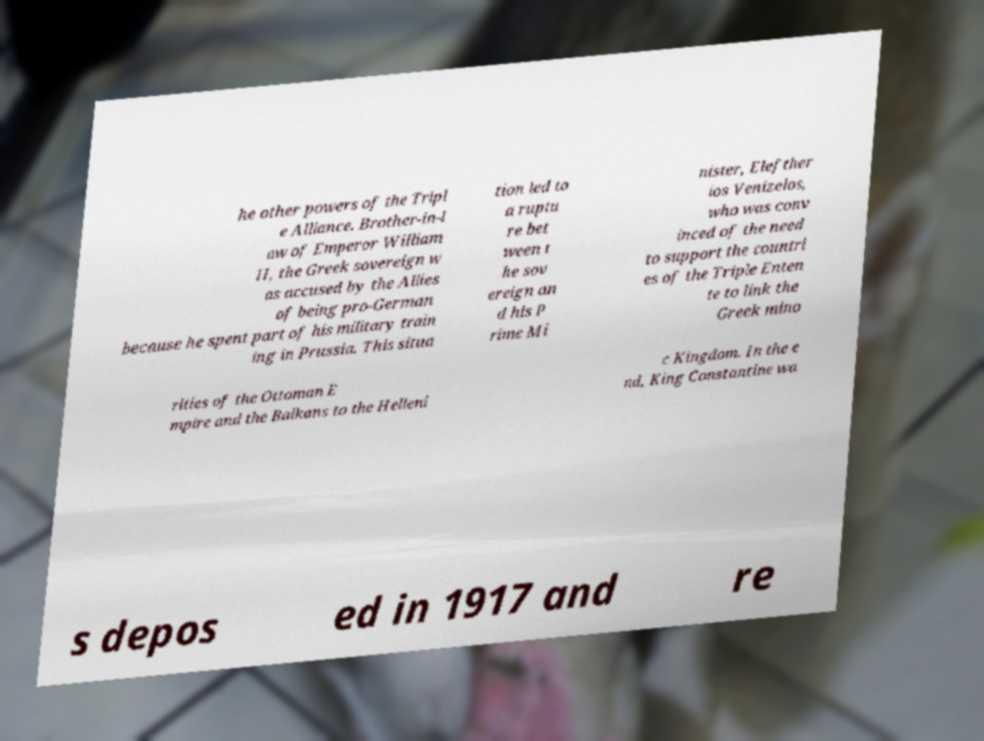What messages or text are displayed in this image? I need them in a readable, typed format. he other powers of the Tripl e Alliance. Brother-in-l aw of Emperor William II, the Greek sovereign w as accused by the Allies of being pro-German because he spent part of his military train ing in Prussia. This situa tion led to a ruptu re bet ween t he sov ereign an d his P rime Mi nister, Elefther ios Venizelos, who was conv inced of the need to support the countri es of the Triple Enten te to link the Greek mino rities of the Ottoman E mpire and the Balkans to the Helleni c Kingdom. In the e nd, King Constantine wa s depos ed in 1917 and re 